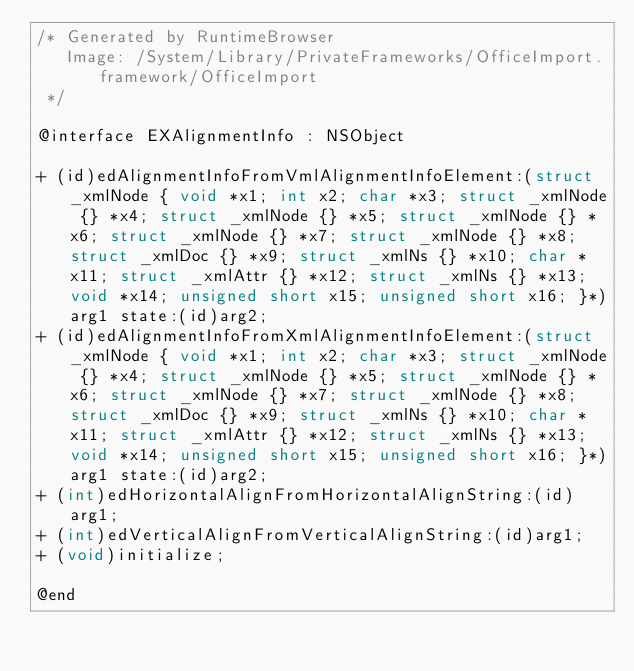<code> <loc_0><loc_0><loc_500><loc_500><_C_>/* Generated by RuntimeBrowser
   Image: /System/Library/PrivateFrameworks/OfficeImport.framework/OfficeImport
 */

@interface EXAlignmentInfo : NSObject

+ (id)edAlignmentInfoFromVmlAlignmentInfoElement:(struct _xmlNode { void *x1; int x2; char *x3; struct _xmlNode {} *x4; struct _xmlNode {} *x5; struct _xmlNode {} *x6; struct _xmlNode {} *x7; struct _xmlNode {} *x8; struct _xmlDoc {} *x9; struct _xmlNs {} *x10; char *x11; struct _xmlAttr {} *x12; struct _xmlNs {} *x13; void *x14; unsigned short x15; unsigned short x16; }*)arg1 state:(id)arg2;
+ (id)edAlignmentInfoFromXmlAlignmentInfoElement:(struct _xmlNode { void *x1; int x2; char *x3; struct _xmlNode {} *x4; struct _xmlNode {} *x5; struct _xmlNode {} *x6; struct _xmlNode {} *x7; struct _xmlNode {} *x8; struct _xmlDoc {} *x9; struct _xmlNs {} *x10; char *x11; struct _xmlAttr {} *x12; struct _xmlNs {} *x13; void *x14; unsigned short x15; unsigned short x16; }*)arg1 state:(id)arg2;
+ (int)edHorizontalAlignFromHorizontalAlignString:(id)arg1;
+ (int)edVerticalAlignFromVerticalAlignString:(id)arg1;
+ (void)initialize;

@end
</code> 